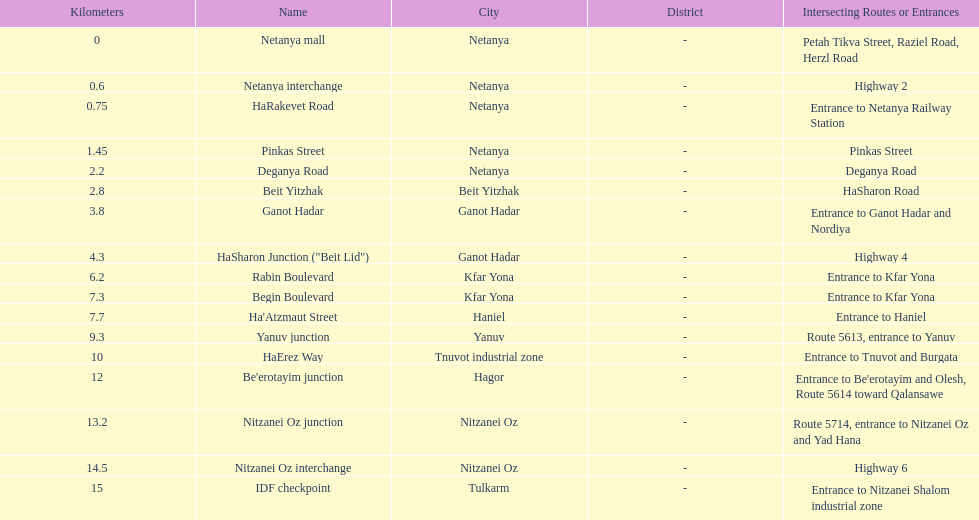Which section is longest?? IDF checkpoint. 